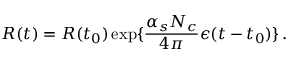<formula> <loc_0><loc_0><loc_500><loc_500>R ( t ) = R ( t _ { 0 } ) \exp \{ { \frac { \alpha _ { s } N _ { c } } { 4 \pi } } \epsilon ( t - t _ { 0 } ) \} \, .</formula> 